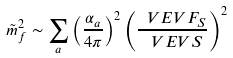<formula> <loc_0><loc_0><loc_500><loc_500>\tilde { m } _ { f } ^ { 2 } \sim \sum _ { a } \left ( \frac { \alpha _ { a } } { 4 \pi } \right ) ^ { 2 } \left ( \frac { \ V E V { F _ { S } } } { \ V E V { S } } \right ) ^ { 2 }</formula> 